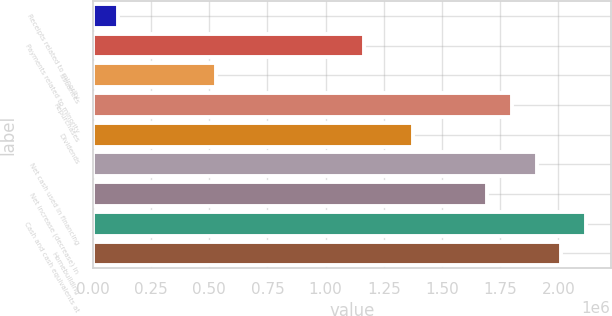<chart> <loc_0><loc_0><loc_500><loc_500><bar_chart><fcel>Receipts related to minority<fcel>Payments related to minority<fcel>Issuances<fcel>Repurchases<fcel>Dividends<fcel>Net cash used in financing<fcel>Net increase (decrease) in<fcel>Cash and cash equivalents at<fcel>Homebuilding<nl><fcel>106143<fcel>1.16525e+06<fcel>529788<fcel>1.80072e+06<fcel>1.37708e+06<fcel>1.90663e+06<fcel>1.69481e+06<fcel>2.11845e+06<fcel>2.01254e+06<nl></chart> 